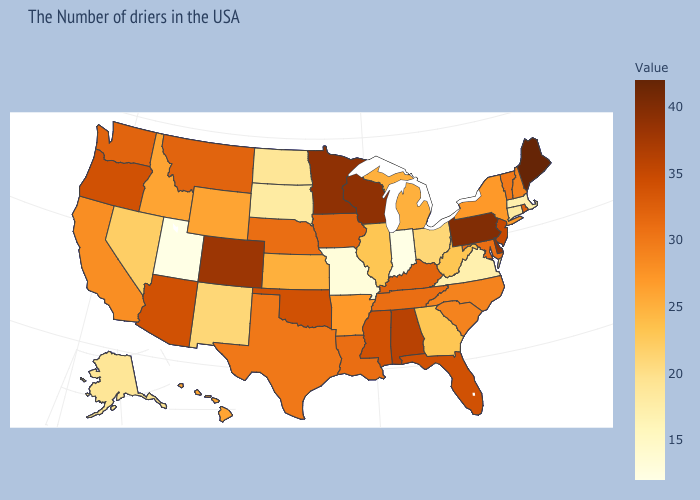Which states have the lowest value in the USA?
Quick response, please. Indiana, Utah. Does Indiana have the lowest value in the MidWest?
Short answer required. Yes. Does Maine have the highest value in the USA?
Concise answer only. Yes. Does Colorado have the highest value in the West?
Answer briefly. Yes. Among the states that border New York , does Connecticut have the lowest value?
Write a very short answer. No. Does Hawaii have a lower value than Missouri?
Give a very brief answer. No. Among the states that border North Carolina , does Tennessee have the highest value?
Be succinct. Yes. 